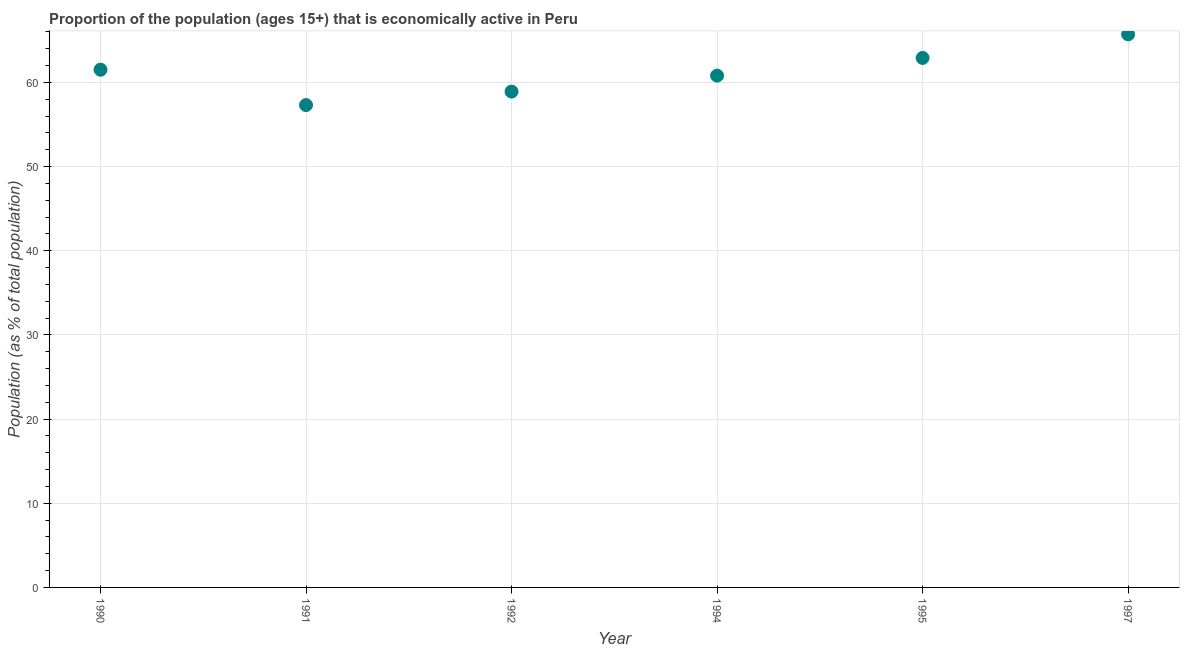What is the percentage of economically active population in 1997?
Your answer should be very brief. 65.7. Across all years, what is the maximum percentage of economically active population?
Give a very brief answer. 65.7. Across all years, what is the minimum percentage of economically active population?
Provide a succinct answer. 57.3. In which year was the percentage of economically active population maximum?
Provide a succinct answer. 1997. What is the sum of the percentage of economically active population?
Offer a very short reply. 367.1. What is the difference between the percentage of economically active population in 1990 and 1991?
Ensure brevity in your answer.  4.2. What is the average percentage of economically active population per year?
Your answer should be very brief. 61.18. What is the median percentage of economically active population?
Your answer should be compact. 61.15. What is the ratio of the percentage of economically active population in 1992 to that in 1994?
Provide a succinct answer. 0.97. Is the percentage of economically active population in 1991 less than that in 1995?
Your answer should be compact. Yes. Is the difference between the percentage of economically active population in 1990 and 1997 greater than the difference between any two years?
Your answer should be compact. No. What is the difference between the highest and the second highest percentage of economically active population?
Ensure brevity in your answer.  2.8. What is the difference between the highest and the lowest percentage of economically active population?
Your response must be concise. 8.4. Does the graph contain any zero values?
Keep it short and to the point. No. What is the title of the graph?
Keep it short and to the point. Proportion of the population (ages 15+) that is economically active in Peru. What is the label or title of the X-axis?
Make the answer very short. Year. What is the label or title of the Y-axis?
Provide a short and direct response. Population (as % of total population). What is the Population (as % of total population) in 1990?
Ensure brevity in your answer.  61.5. What is the Population (as % of total population) in 1991?
Your answer should be very brief. 57.3. What is the Population (as % of total population) in 1992?
Provide a succinct answer. 58.9. What is the Population (as % of total population) in 1994?
Offer a very short reply. 60.8. What is the Population (as % of total population) in 1995?
Ensure brevity in your answer.  62.9. What is the Population (as % of total population) in 1997?
Your answer should be compact. 65.7. What is the difference between the Population (as % of total population) in 1990 and 1991?
Make the answer very short. 4.2. What is the difference between the Population (as % of total population) in 1990 and 1992?
Keep it short and to the point. 2.6. What is the difference between the Population (as % of total population) in 1990 and 1994?
Your answer should be very brief. 0.7. What is the difference between the Population (as % of total population) in 1990 and 1995?
Make the answer very short. -1.4. What is the difference between the Population (as % of total population) in 1990 and 1997?
Your response must be concise. -4.2. What is the difference between the Population (as % of total population) in 1992 and 1995?
Give a very brief answer. -4. What is the difference between the Population (as % of total population) in 1994 and 1995?
Offer a very short reply. -2.1. What is the difference between the Population (as % of total population) in 1994 and 1997?
Ensure brevity in your answer.  -4.9. What is the difference between the Population (as % of total population) in 1995 and 1997?
Provide a short and direct response. -2.8. What is the ratio of the Population (as % of total population) in 1990 to that in 1991?
Offer a terse response. 1.07. What is the ratio of the Population (as % of total population) in 1990 to that in 1992?
Offer a very short reply. 1.04. What is the ratio of the Population (as % of total population) in 1990 to that in 1995?
Keep it short and to the point. 0.98. What is the ratio of the Population (as % of total population) in 1990 to that in 1997?
Your answer should be very brief. 0.94. What is the ratio of the Population (as % of total population) in 1991 to that in 1992?
Offer a terse response. 0.97. What is the ratio of the Population (as % of total population) in 1991 to that in 1994?
Provide a succinct answer. 0.94. What is the ratio of the Population (as % of total population) in 1991 to that in 1995?
Your answer should be compact. 0.91. What is the ratio of the Population (as % of total population) in 1991 to that in 1997?
Keep it short and to the point. 0.87. What is the ratio of the Population (as % of total population) in 1992 to that in 1994?
Provide a short and direct response. 0.97. What is the ratio of the Population (as % of total population) in 1992 to that in 1995?
Give a very brief answer. 0.94. What is the ratio of the Population (as % of total population) in 1992 to that in 1997?
Make the answer very short. 0.9. What is the ratio of the Population (as % of total population) in 1994 to that in 1997?
Make the answer very short. 0.93. 